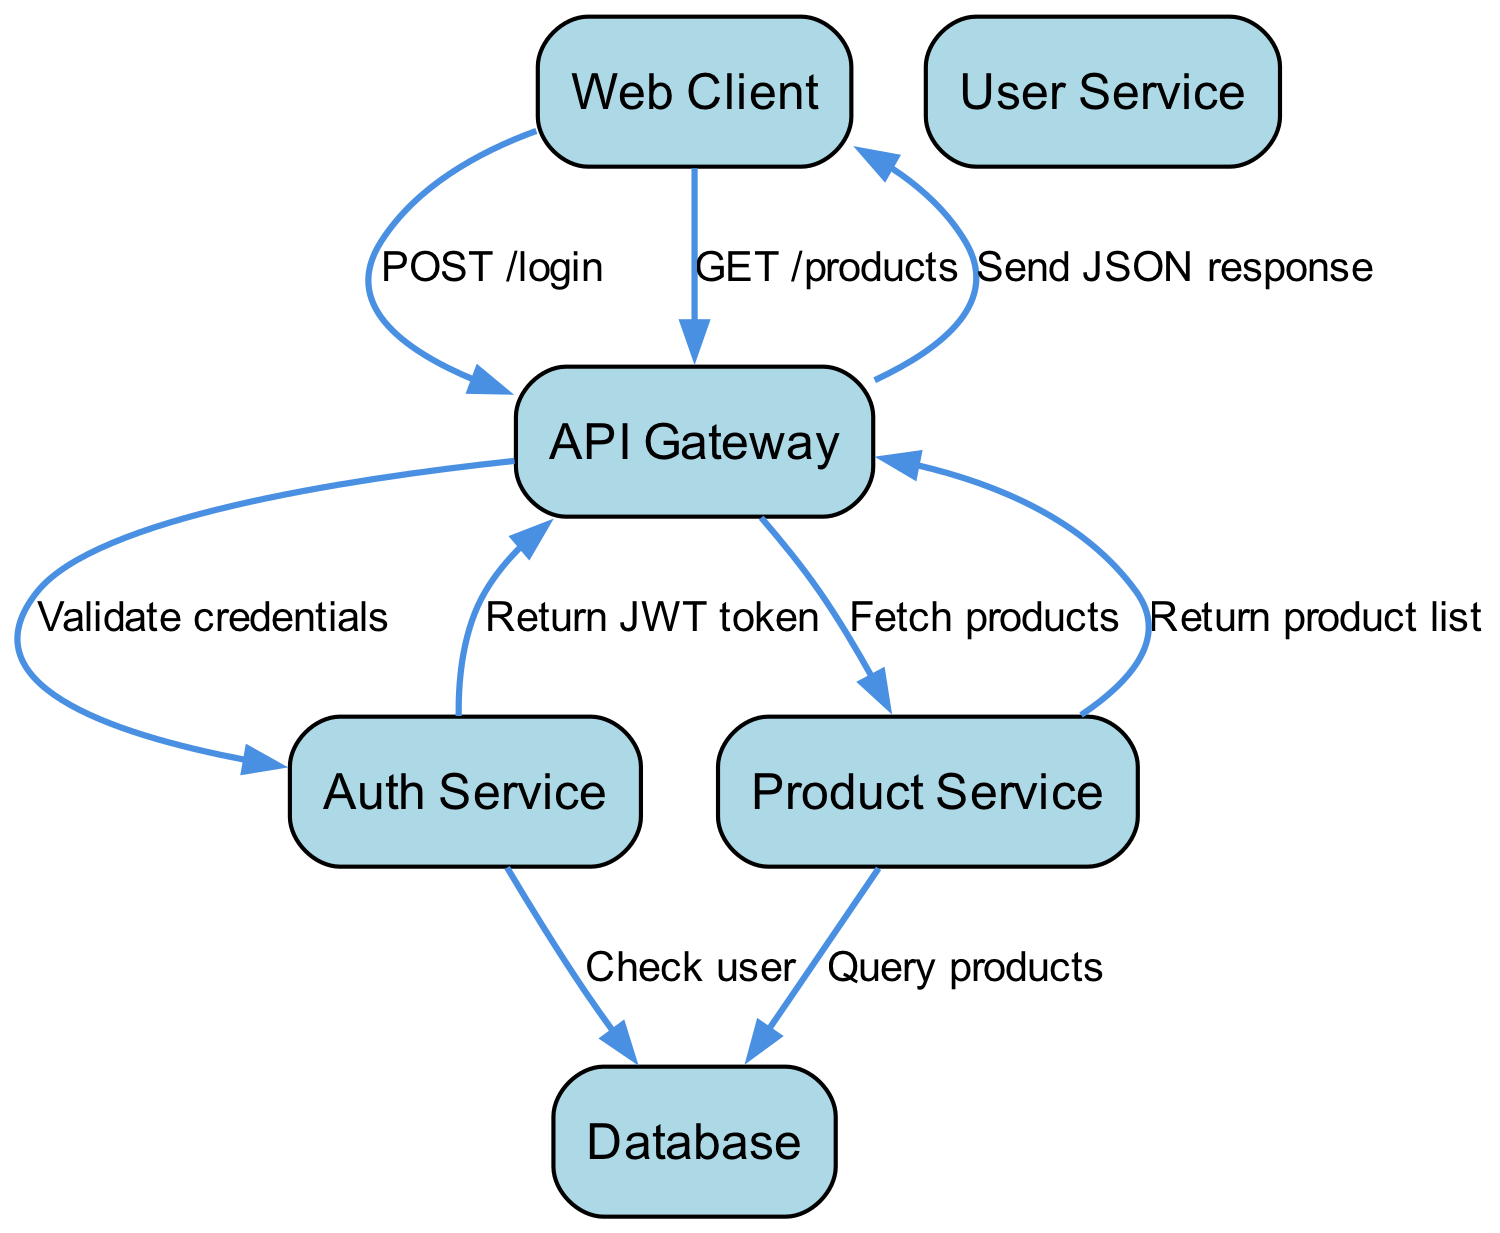What is the first action taken by the Web Client? The Web Client initiates the interaction by making a POST request to the API Gateway for the login action. This can be seen as the first interaction in the sequence diagram.
Answer: POST /login How many services are involved in this sequence diagram? By counting the unique services listed as actors in the diagram—User Service, Auth Service, Product Service, and Database—there are four services involved.
Answer: 4 Which service validates user credentials? The Auth Service is responsible for validating the user credentials after the Web Client sends the login request to the API Gateway. This is represented by the interaction from API Gateway to Auth Service.
Answer: Auth Service What does the Auth Service return to the API Gateway? After validating the user credentials, the Auth Service returns a JWT token to the API Gateway. This is indicated by the interaction labeled "Return JWT token" in the diagram.
Answer: JWT token What action is taken by the Product Service? The Product Service takes the action to query products from the Database after receiving a request from the API Gateway to fetch products. This can be found in the directed interaction from Product Service to Database.
Answer: Query products How many total interactions are shown in this sequence diagram? By counting all the actions listed in the interactions section, we see that there are a total of eight distinct interactions depicted in the diagram.
Answer: 8 What does the API Gateway send back to the Web Client? The API Gateway sends a JSON response back to the Web Client after fetching the products from the Product Service. This is noted as the last interaction in the flow of the diagram.
Answer: Send JSON response Which actor performs a query to the Database? The Product Service is the actor that performs a query to the Database in order to retrieve the product information needed to respond to the API Gateway. This is indicated by the interaction labeled "Query products."
Answer: Product Service 